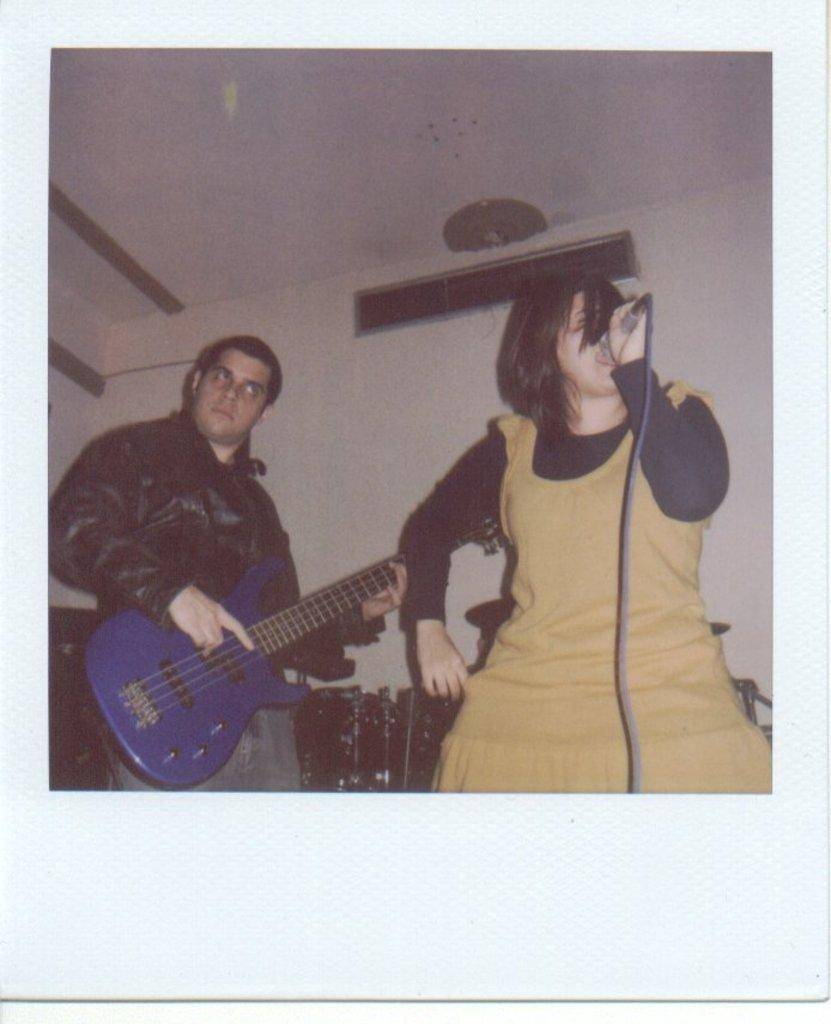How many people are in the image? There are two persons in the image. What is one person doing in the image? One person is playing a guitar. What is the other person holding in the image? The other person is holding a microphone in her hand. What type of toy is the person playing the guitar using in the image? There is no toy present in the image; the person is playing a guitar, which is a musical instrument. 